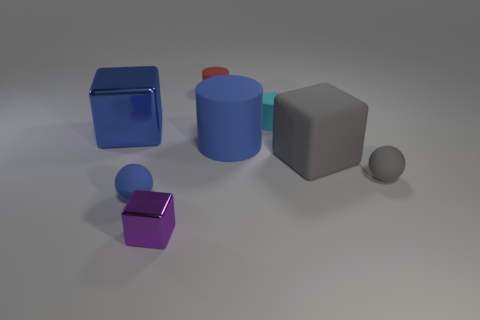What number of other objects are there of the same material as the blue sphere?
Make the answer very short. 5. How many purple things are tiny metal cubes or cubes?
Give a very brief answer. 1. What is the size of the cylinder that is the same color as the large metallic cube?
Your response must be concise. Large. How many tiny cubes are left of the tiny blue object?
Make the answer very short. 0. There is a ball right of the gray matte thing that is behind the ball to the right of the small red rubber object; what size is it?
Your response must be concise. Small. Is there a purple shiny thing behind the metal cube to the right of the large blue thing on the left side of the red rubber thing?
Make the answer very short. No. Is the number of small blue rubber things greater than the number of large brown metallic cylinders?
Offer a terse response. Yes. The metal object behind the tiny purple thing is what color?
Make the answer very short. Blue. Is the number of purple cubes to the right of the small red cylinder greater than the number of small blue balls?
Make the answer very short. No. Is the material of the tiny purple block the same as the cyan cylinder?
Your answer should be very brief. No. 